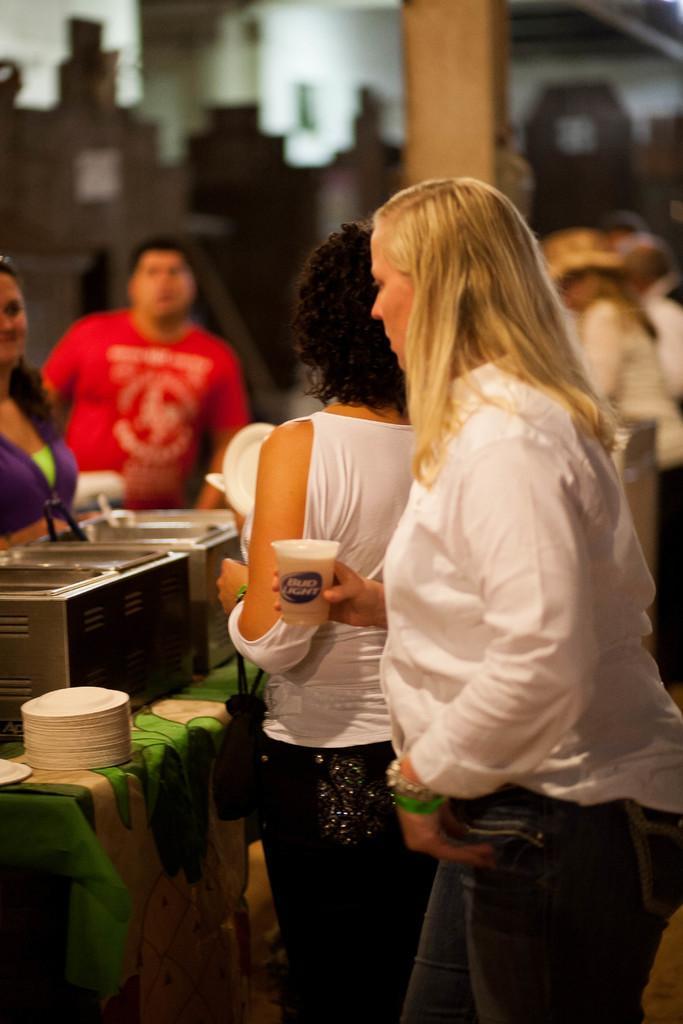How would you summarize this image in a sentence or two? There are people standing and some objects on the table in the foreground area of the image and the background is blurry. 